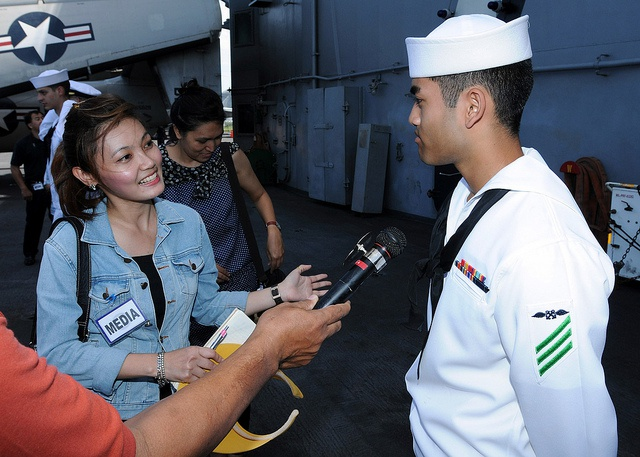Describe the objects in this image and their specific colors. I can see people in darkgray, white, lavender, and black tones, people in darkgray, black, and gray tones, people in darkgray, brown, salmon, and red tones, people in darkgray, black, gray, maroon, and navy tones, and people in darkgray, black, and gray tones in this image. 